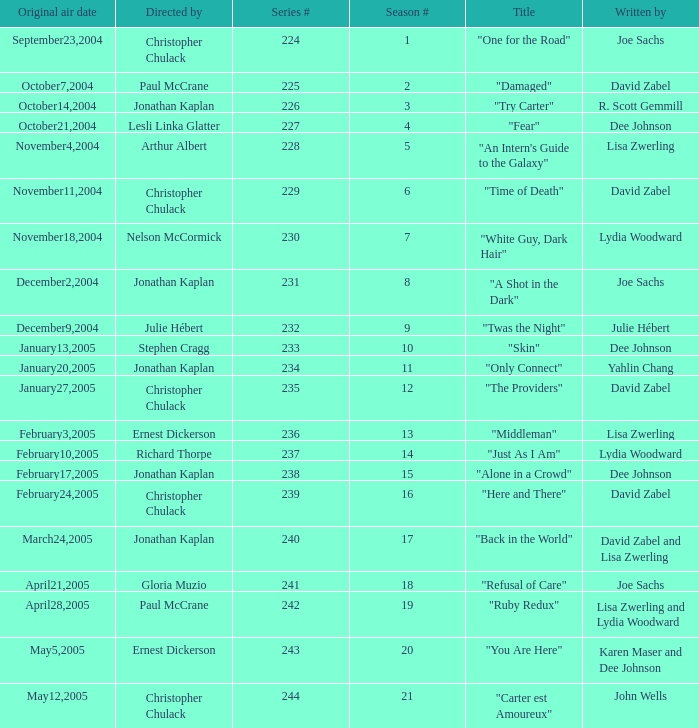Name who directed the episode for the series number 236 Ernest Dickerson. 